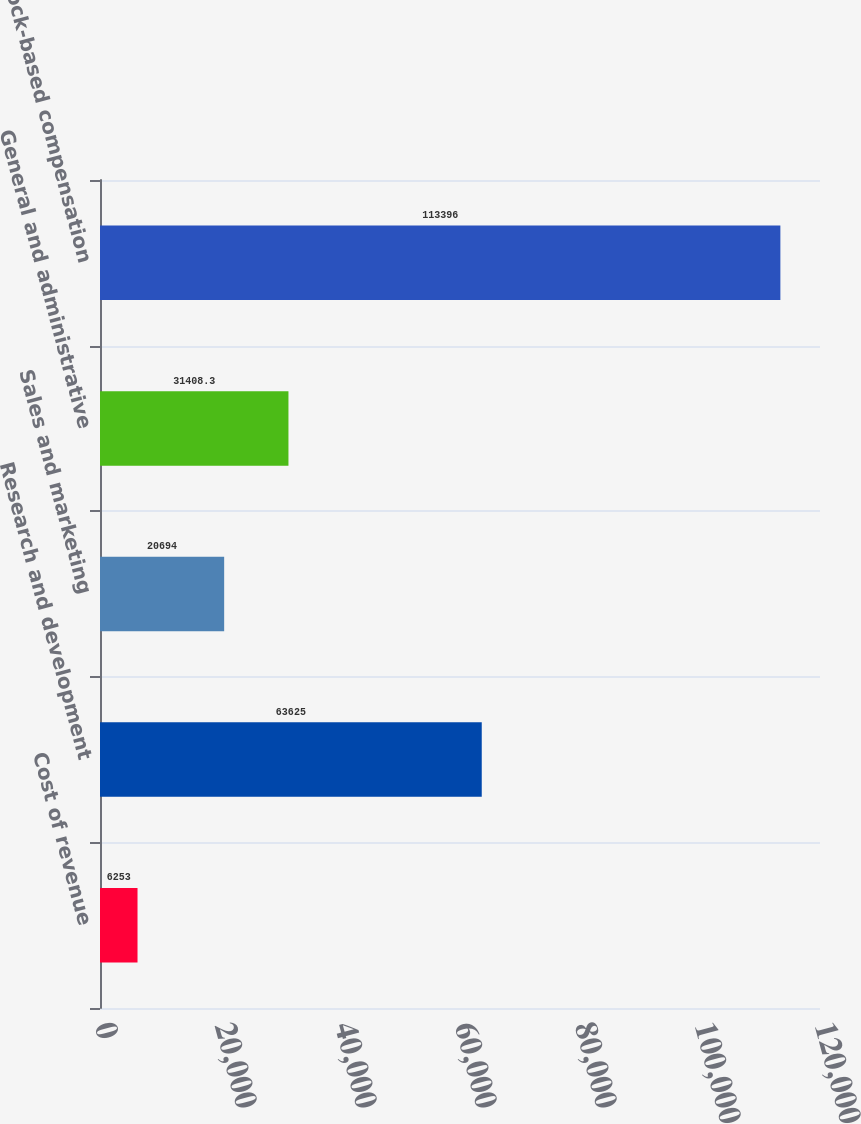Convert chart. <chart><loc_0><loc_0><loc_500><loc_500><bar_chart><fcel>Cost of revenue<fcel>Research and development<fcel>Sales and marketing<fcel>General and administrative<fcel>Total stock-based compensation<nl><fcel>6253<fcel>63625<fcel>20694<fcel>31408.3<fcel>113396<nl></chart> 